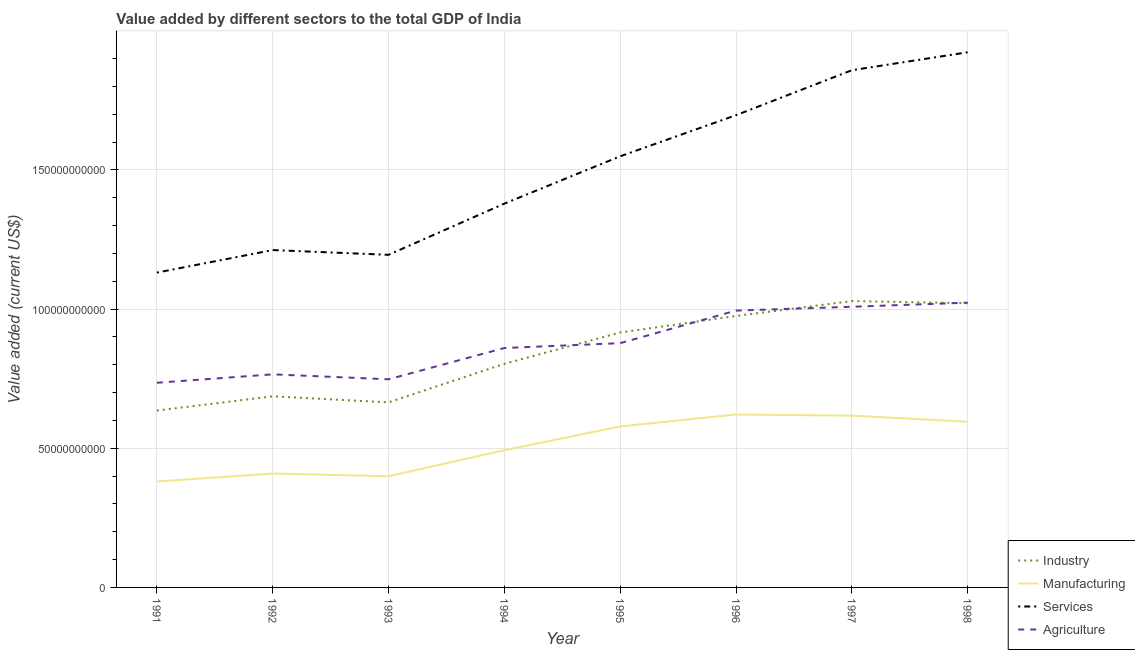Is the number of lines equal to the number of legend labels?
Ensure brevity in your answer.  Yes. What is the value added by industrial sector in 1993?
Keep it short and to the point. 6.65e+1. Across all years, what is the maximum value added by agricultural sector?
Make the answer very short. 1.02e+11. Across all years, what is the minimum value added by services sector?
Your answer should be compact. 1.13e+11. In which year was the value added by services sector maximum?
Your answer should be compact. 1998. In which year was the value added by industrial sector minimum?
Offer a very short reply. 1991. What is the total value added by manufacturing sector in the graph?
Offer a very short reply. 4.09e+11. What is the difference between the value added by services sector in 1992 and that in 1993?
Your answer should be compact. 1.71e+09. What is the difference between the value added by agricultural sector in 1992 and the value added by industrial sector in 1998?
Keep it short and to the point. -2.56e+1. What is the average value added by manufacturing sector per year?
Provide a succinct answer. 5.12e+1. In the year 1997, what is the difference between the value added by agricultural sector and value added by manufacturing sector?
Ensure brevity in your answer.  3.91e+1. In how many years, is the value added by services sector greater than 110000000000 US$?
Provide a succinct answer. 8. What is the ratio of the value added by agricultural sector in 1992 to that in 1998?
Your answer should be compact. 0.75. Is the value added by services sector in 1991 less than that in 1994?
Your response must be concise. Yes. What is the difference between the highest and the second highest value added by services sector?
Make the answer very short. 6.45e+09. What is the difference between the highest and the lowest value added by agricultural sector?
Offer a very short reply. 2.88e+1. Is the sum of the value added by agricultural sector in 1993 and 1995 greater than the maximum value added by industrial sector across all years?
Make the answer very short. Yes. Is the value added by manufacturing sector strictly greater than the value added by agricultural sector over the years?
Give a very brief answer. No. Is the value added by agricultural sector strictly less than the value added by manufacturing sector over the years?
Offer a very short reply. No. What is the difference between two consecutive major ticks on the Y-axis?
Your response must be concise. 5.00e+1. Does the graph contain grids?
Ensure brevity in your answer.  Yes. Where does the legend appear in the graph?
Keep it short and to the point. Bottom right. How many legend labels are there?
Your answer should be very brief. 4. What is the title of the graph?
Offer a terse response. Value added by different sectors to the total GDP of India. Does "Sweden" appear as one of the legend labels in the graph?
Your response must be concise. No. What is the label or title of the Y-axis?
Keep it short and to the point. Value added (current US$). What is the Value added (current US$) in Industry in 1991?
Your answer should be very brief. 6.36e+1. What is the Value added (current US$) of Manufacturing in 1991?
Provide a succinct answer. 3.81e+1. What is the Value added (current US$) in Services in 1991?
Keep it short and to the point. 1.13e+11. What is the Value added (current US$) of Agriculture in 1991?
Ensure brevity in your answer.  7.35e+1. What is the Value added (current US$) of Industry in 1992?
Provide a short and direct response. 6.87e+1. What is the Value added (current US$) in Manufacturing in 1992?
Your answer should be compact. 4.09e+1. What is the Value added (current US$) in Services in 1992?
Offer a very short reply. 1.21e+11. What is the Value added (current US$) of Agriculture in 1992?
Offer a very short reply. 7.66e+1. What is the Value added (current US$) of Industry in 1993?
Give a very brief answer. 6.65e+1. What is the Value added (current US$) in Manufacturing in 1993?
Ensure brevity in your answer.  3.99e+1. What is the Value added (current US$) in Services in 1993?
Offer a terse response. 1.20e+11. What is the Value added (current US$) of Agriculture in 1993?
Keep it short and to the point. 7.48e+1. What is the Value added (current US$) in Industry in 1994?
Give a very brief answer. 8.03e+1. What is the Value added (current US$) of Manufacturing in 1994?
Provide a short and direct response. 4.93e+1. What is the Value added (current US$) of Services in 1994?
Your answer should be compact. 1.38e+11. What is the Value added (current US$) of Agriculture in 1994?
Give a very brief answer. 8.60e+1. What is the Value added (current US$) of Industry in 1995?
Your answer should be compact. 9.16e+1. What is the Value added (current US$) of Manufacturing in 1995?
Offer a very short reply. 5.78e+1. What is the Value added (current US$) in Services in 1995?
Your response must be concise. 1.55e+11. What is the Value added (current US$) of Agriculture in 1995?
Keep it short and to the point. 8.78e+1. What is the Value added (current US$) in Industry in 1996?
Ensure brevity in your answer.  9.75e+1. What is the Value added (current US$) in Manufacturing in 1996?
Offer a terse response. 6.21e+1. What is the Value added (current US$) in Services in 1996?
Offer a very short reply. 1.70e+11. What is the Value added (current US$) of Agriculture in 1996?
Make the answer very short. 9.95e+1. What is the Value added (current US$) in Industry in 1997?
Ensure brevity in your answer.  1.03e+11. What is the Value added (current US$) of Manufacturing in 1997?
Keep it short and to the point. 6.17e+1. What is the Value added (current US$) in Services in 1997?
Offer a very short reply. 1.86e+11. What is the Value added (current US$) of Agriculture in 1997?
Provide a succinct answer. 1.01e+11. What is the Value added (current US$) in Industry in 1998?
Offer a terse response. 1.02e+11. What is the Value added (current US$) in Manufacturing in 1998?
Your response must be concise. 5.95e+1. What is the Value added (current US$) in Services in 1998?
Offer a terse response. 1.92e+11. What is the Value added (current US$) of Agriculture in 1998?
Make the answer very short. 1.02e+11. Across all years, what is the maximum Value added (current US$) in Industry?
Keep it short and to the point. 1.03e+11. Across all years, what is the maximum Value added (current US$) of Manufacturing?
Your answer should be very brief. 6.21e+1. Across all years, what is the maximum Value added (current US$) in Services?
Your answer should be compact. 1.92e+11. Across all years, what is the maximum Value added (current US$) in Agriculture?
Your answer should be compact. 1.02e+11. Across all years, what is the minimum Value added (current US$) of Industry?
Give a very brief answer. 6.36e+1. Across all years, what is the minimum Value added (current US$) in Manufacturing?
Give a very brief answer. 3.81e+1. Across all years, what is the minimum Value added (current US$) in Services?
Offer a terse response. 1.13e+11. Across all years, what is the minimum Value added (current US$) in Agriculture?
Ensure brevity in your answer.  7.35e+1. What is the total Value added (current US$) of Industry in the graph?
Provide a succinct answer. 6.73e+11. What is the total Value added (current US$) in Manufacturing in the graph?
Your response must be concise. 4.09e+11. What is the total Value added (current US$) in Services in the graph?
Your response must be concise. 1.19e+12. What is the total Value added (current US$) of Agriculture in the graph?
Ensure brevity in your answer.  7.01e+11. What is the difference between the Value added (current US$) of Industry in 1991 and that in 1992?
Give a very brief answer. -5.10e+09. What is the difference between the Value added (current US$) of Manufacturing in 1991 and that in 1992?
Your response must be concise. -2.87e+09. What is the difference between the Value added (current US$) of Services in 1991 and that in 1992?
Provide a succinct answer. -8.09e+09. What is the difference between the Value added (current US$) in Agriculture in 1991 and that in 1992?
Provide a short and direct response. -3.02e+09. What is the difference between the Value added (current US$) of Industry in 1991 and that in 1993?
Keep it short and to the point. -2.94e+09. What is the difference between the Value added (current US$) of Manufacturing in 1991 and that in 1993?
Ensure brevity in your answer.  -1.90e+09. What is the difference between the Value added (current US$) of Services in 1991 and that in 1993?
Keep it short and to the point. -6.38e+09. What is the difference between the Value added (current US$) of Agriculture in 1991 and that in 1993?
Keep it short and to the point. -1.25e+09. What is the difference between the Value added (current US$) of Industry in 1991 and that in 1994?
Your response must be concise. -1.68e+1. What is the difference between the Value added (current US$) of Manufacturing in 1991 and that in 1994?
Keep it short and to the point. -1.13e+1. What is the difference between the Value added (current US$) in Services in 1991 and that in 1994?
Your answer should be very brief. -2.48e+1. What is the difference between the Value added (current US$) in Agriculture in 1991 and that in 1994?
Give a very brief answer. -1.25e+1. What is the difference between the Value added (current US$) of Industry in 1991 and that in 1995?
Make the answer very short. -2.80e+1. What is the difference between the Value added (current US$) of Manufacturing in 1991 and that in 1995?
Offer a very short reply. -1.98e+1. What is the difference between the Value added (current US$) in Services in 1991 and that in 1995?
Keep it short and to the point. -4.18e+1. What is the difference between the Value added (current US$) of Agriculture in 1991 and that in 1995?
Offer a terse response. -1.42e+1. What is the difference between the Value added (current US$) of Industry in 1991 and that in 1996?
Your answer should be compact. -3.40e+1. What is the difference between the Value added (current US$) of Manufacturing in 1991 and that in 1996?
Keep it short and to the point. -2.41e+1. What is the difference between the Value added (current US$) in Services in 1991 and that in 1996?
Your answer should be compact. -5.66e+1. What is the difference between the Value added (current US$) in Agriculture in 1991 and that in 1996?
Provide a succinct answer. -2.59e+1. What is the difference between the Value added (current US$) of Industry in 1991 and that in 1997?
Offer a terse response. -3.93e+1. What is the difference between the Value added (current US$) in Manufacturing in 1991 and that in 1997?
Keep it short and to the point. -2.37e+1. What is the difference between the Value added (current US$) of Services in 1991 and that in 1997?
Offer a terse response. -7.27e+1. What is the difference between the Value added (current US$) of Agriculture in 1991 and that in 1997?
Your answer should be very brief. -2.73e+1. What is the difference between the Value added (current US$) of Industry in 1991 and that in 1998?
Your answer should be compact. -3.86e+1. What is the difference between the Value added (current US$) of Manufacturing in 1991 and that in 1998?
Offer a terse response. -2.15e+1. What is the difference between the Value added (current US$) of Services in 1991 and that in 1998?
Provide a succinct answer. -7.92e+1. What is the difference between the Value added (current US$) in Agriculture in 1991 and that in 1998?
Provide a succinct answer. -2.88e+1. What is the difference between the Value added (current US$) in Industry in 1992 and that in 1993?
Provide a succinct answer. 2.17e+09. What is the difference between the Value added (current US$) in Manufacturing in 1992 and that in 1993?
Keep it short and to the point. 9.77e+08. What is the difference between the Value added (current US$) of Services in 1992 and that in 1993?
Offer a very short reply. 1.71e+09. What is the difference between the Value added (current US$) in Agriculture in 1992 and that in 1993?
Give a very brief answer. 1.78e+09. What is the difference between the Value added (current US$) in Industry in 1992 and that in 1994?
Keep it short and to the point. -1.17e+1. What is the difference between the Value added (current US$) in Manufacturing in 1992 and that in 1994?
Provide a short and direct response. -8.38e+09. What is the difference between the Value added (current US$) in Services in 1992 and that in 1994?
Give a very brief answer. -1.67e+1. What is the difference between the Value added (current US$) of Agriculture in 1992 and that in 1994?
Provide a succinct answer. -9.46e+09. What is the difference between the Value added (current US$) of Industry in 1992 and that in 1995?
Your answer should be compact. -2.29e+1. What is the difference between the Value added (current US$) of Manufacturing in 1992 and that in 1995?
Your answer should be very brief. -1.69e+1. What is the difference between the Value added (current US$) of Services in 1992 and that in 1995?
Make the answer very short. -3.37e+1. What is the difference between the Value added (current US$) of Agriculture in 1992 and that in 1995?
Keep it short and to the point. -1.12e+1. What is the difference between the Value added (current US$) in Industry in 1992 and that in 1996?
Ensure brevity in your answer.  -2.89e+1. What is the difference between the Value added (current US$) in Manufacturing in 1992 and that in 1996?
Offer a very short reply. -2.12e+1. What is the difference between the Value added (current US$) of Services in 1992 and that in 1996?
Provide a succinct answer. -4.85e+1. What is the difference between the Value added (current US$) of Agriculture in 1992 and that in 1996?
Provide a short and direct response. -2.29e+1. What is the difference between the Value added (current US$) of Industry in 1992 and that in 1997?
Your response must be concise. -3.42e+1. What is the difference between the Value added (current US$) in Manufacturing in 1992 and that in 1997?
Keep it short and to the point. -2.08e+1. What is the difference between the Value added (current US$) in Services in 1992 and that in 1997?
Offer a terse response. -6.46e+1. What is the difference between the Value added (current US$) in Agriculture in 1992 and that in 1997?
Provide a short and direct response. -2.43e+1. What is the difference between the Value added (current US$) in Industry in 1992 and that in 1998?
Offer a terse response. -3.35e+1. What is the difference between the Value added (current US$) of Manufacturing in 1992 and that in 1998?
Your answer should be compact. -1.86e+1. What is the difference between the Value added (current US$) in Services in 1992 and that in 1998?
Provide a succinct answer. -7.11e+1. What is the difference between the Value added (current US$) in Agriculture in 1992 and that in 1998?
Your response must be concise. -2.58e+1. What is the difference between the Value added (current US$) of Industry in 1993 and that in 1994?
Provide a short and direct response. -1.39e+1. What is the difference between the Value added (current US$) of Manufacturing in 1993 and that in 1994?
Offer a very short reply. -9.36e+09. What is the difference between the Value added (current US$) of Services in 1993 and that in 1994?
Give a very brief answer. -1.84e+1. What is the difference between the Value added (current US$) in Agriculture in 1993 and that in 1994?
Offer a terse response. -1.12e+1. What is the difference between the Value added (current US$) of Industry in 1993 and that in 1995?
Ensure brevity in your answer.  -2.51e+1. What is the difference between the Value added (current US$) of Manufacturing in 1993 and that in 1995?
Offer a terse response. -1.79e+1. What is the difference between the Value added (current US$) in Services in 1993 and that in 1995?
Your answer should be very brief. -3.54e+1. What is the difference between the Value added (current US$) in Agriculture in 1993 and that in 1995?
Give a very brief answer. -1.30e+1. What is the difference between the Value added (current US$) in Industry in 1993 and that in 1996?
Your response must be concise. -3.10e+1. What is the difference between the Value added (current US$) of Manufacturing in 1993 and that in 1996?
Keep it short and to the point. -2.22e+1. What is the difference between the Value added (current US$) in Services in 1993 and that in 1996?
Offer a terse response. -5.02e+1. What is the difference between the Value added (current US$) in Agriculture in 1993 and that in 1996?
Provide a succinct answer. -2.47e+1. What is the difference between the Value added (current US$) in Industry in 1993 and that in 1997?
Your answer should be compact. -3.64e+1. What is the difference between the Value added (current US$) in Manufacturing in 1993 and that in 1997?
Provide a short and direct response. -2.18e+1. What is the difference between the Value added (current US$) in Services in 1993 and that in 1997?
Your answer should be very brief. -6.63e+1. What is the difference between the Value added (current US$) of Agriculture in 1993 and that in 1997?
Your response must be concise. -2.61e+1. What is the difference between the Value added (current US$) of Industry in 1993 and that in 1998?
Keep it short and to the point. -3.56e+1. What is the difference between the Value added (current US$) in Manufacturing in 1993 and that in 1998?
Make the answer very short. -1.96e+1. What is the difference between the Value added (current US$) in Services in 1993 and that in 1998?
Offer a very short reply. -7.28e+1. What is the difference between the Value added (current US$) of Agriculture in 1993 and that in 1998?
Give a very brief answer. -2.75e+1. What is the difference between the Value added (current US$) in Industry in 1994 and that in 1995?
Offer a very short reply. -1.13e+1. What is the difference between the Value added (current US$) in Manufacturing in 1994 and that in 1995?
Provide a short and direct response. -8.54e+09. What is the difference between the Value added (current US$) in Services in 1994 and that in 1995?
Provide a succinct answer. -1.70e+1. What is the difference between the Value added (current US$) of Agriculture in 1994 and that in 1995?
Make the answer very short. -1.74e+09. What is the difference between the Value added (current US$) of Industry in 1994 and that in 1996?
Your response must be concise. -1.72e+1. What is the difference between the Value added (current US$) of Manufacturing in 1994 and that in 1996?
Provide a short and direct response. -1.28e+1. What is the difference between the Value added (current US$) of Services in 1994 and that in 1996?
Your response must be concise. -3.18e+1. What is the difference between the Value added (current US$) of Agriculture in 1994 and that in 1996?
Offer a very short reply. -1.34e+1. What is the difference between the Value added (current US$) in Industry in 1994 and that in 1997?
Ensure brevity in your answer.  -2.25e+1. What is the difference between the Value added (current US$) of Manufacturing in 1994 and that in 1997?
Keep it short and to the point. -1.24e+1. What is the difference between the Value added (current US$) in Services in 1994 and that in 1997?
Provide a succinct answer. -4.79e+1. What is the difference between the Value added (current US$) in Agriculture in 1994 and that in 1997?
Provide a succinct answer. -1.48e+1. What is the difference between the Value added (current US$) in Industry in 1994 and that in 1998?
Keep it short and to the point. -2.18e+1. What is the difference between the Value added (current US$) in Manufacturing in 1994 and that in 1998?
Provide a succinct answer. -1.02e+1. What is the difference between the Value added (current US$) of Services in 1994 and that in 1998?
Provide a succinct answer. -5.44e+1. What is the difference between the Value added (current US$) of Agriculture in 1994 and that in 1998?
Offer a very short reply. -1.63e+1. What is the difference between the Value added (current US$) in Industry in 1995 and that in 1996?
Make the answer very short. -5.94e+09. What is the difference between the Value added (current US$) in Manufacturing in 1995 and that in 1996?
Your answer should be compact. -4.29e+09. What is the difference between the Value added (current US$) in Services in 1995 and that in 1996?
Provide a succinct answer. -1.48e+1. What is the difference between the Value added (current US$) of Agriculture in 1995 and that in 1996?
Provide a short and direct response. -1.17e+1. What is the difference between the Value added (current US$) of Industry in 1995 and that in 1997?
Keep it short and to the point. -1.13e+1. What is the difference between the Value added (current US$) of Manufacturing in 1995 and that in 1997?
Provide a short and direct response. -3.89e+09. What is the difference between the Value added (current US$) of Services in 1995 and that in 1997?
Keep it short and to the point. -3.09e+1. What is the difference between the Value added (current US$) in Agriculture in 1995 and that in 1997?
Offer a very short reply. -1.31e+1. What is the difference between the Value added (current US$) of Industry in 1995 and that in 1998?
Offer a very short reply. -1.05e+1. What is the difference between the Value added (current US$) of Manufacturing in 1995 and that in 1998?
Give a very brief answer. -1.68e+09. What is the difference between the Value added (current US$) in Services in 1995 and that in 1998?
Provide a succinct answer. -3.74e+1. What is the difference between the Value added (current US$) of Agriculture in 1995 and that in 1998?
Your answer should be compact. -1.46e+1. What is the difference between the Value added (current US$) in Industry in 1996 and that in 1997?
Your answer should be compact. -5.35e+09. What is the difference between the Value added (current US$) of Manufacturing in 1996 and that in 1997?
Keep it short and to the point. 3.95e+08. What is the difference between the Value added (current US$) in Services in 1996 and that in 1997?
Your answer should be very brief. -1.62e+1. What is the difference between the Value added (current US$) in Agriculture in 1996 and that in 1997?
Offer a terse response. -1.38e+09. What is the difference between the Value added (current US$) in Industry in 1996 and that in 1998?
Make the answer very short. -4.59e+09. What is the difference between the Value added (current US$) in Manufacturing in 1996 and that in 1998?
Your answer should be very brief. 2.61e+09. What is the difference between the Value added (current US$) of Services in 1996 and that in 1998?
Ensure brevity in your answer.  -2.26e+1. What is the difference between the Value added (current US$) in Agriculture in 1996 and that in 1998?
Provide a succinct answer. -2.85e+09. What is the difference between the Value added (current US$) in Industry in 1997 and that in 1998?
Ensure brevity in your answer.  7.66e+08. What is the difference between the Value added (current US$) of Manufacturing in 1997 and that in 1998?
Give a very brief answer. 2.21e+09. What is the difference between the Value added (current US$) in Services in 1997 and that in 1998?
Your response must be concise. -6.45e+09. What is the difference between the Value added (current US$) of Agriculture in 1997 and that in 1998?
Ensure brevity in your answer.  -1.47e+09. What is the difference between the Value added (current US$) in Industry in 1991 and the Value added (current US$) in Manufacturing in 1992?
Make the answer very short. 2.26e+1. What is the difference between the Value added (current US$) in Industry in 1991 and the Value added (current US$) in Services in 1992?
Your answer should be very brief. -5.77e+1. What is the difference between the Value added (current US$) of Industry in 1991 and the Value added (current US$) of Agriculture in 1992?
Make the answer very short. -1.30e+1. What is the difference between the Value added (current US$) of Manufacturing in 1991 and the Value added (current US$) of Services in 1992?
Provide a succinct answer. -8.32e+1. What is the difference between the Value added (current US$) of Manufacturing in 1991 and the Value added (current US$) of Agriculture in 1992?
Keep it short and to the point. -3.85e+1. What is the difference between the Value added (current US$) of Services in 1991 and the Value added (current US$) of Agriculture in 1992?
Provide a succinct answer. 3.66e+1. What is the difference between the Value added (current US$) in Industry in 1991 and the Value added (current US$) in Manufacturing in 1993?
Your answer should be compact. 2.36e+1. What is the difference between the Value added (current US$) of Industry in 1991 and the Value added (current US$) of Services in 1993?
Ensure brevity in your answer.  -5.59e+1. What is the difference between the Value added (current US$) of Industry in 1991 and the Value added (current US$) of Agriculture in 1993?
Your response must be concise. -1.12e+1. What is the difference between the Value added (current US$) in Manufacturing in 1991 and the Value added (current US$) in Services in 1993?
Your response must be concise. -8.15e+1. What is the difference between the Value added (current US$) in Manufacturing in 1991 and the Value added (current US$) in Agriculture in 1993?
Keep it short and to the point. -3.67e+1. What is the difference between the Value added (current US$) of Services in 1991 and the Value added (current US$) of Agriculture in 1993?
Your answer should be compact. 3.83e+1. What is the difference between the Value added (current US$) of Industry in 1991 and the Value added (current US$) of Manufacturing in 1994?
Make the answer very short. 1.43e+1. What is the difference between the Value added (current US$) of Industry in 1991 and the Value added (current US$) of Services in 1994?
Provide a short and direct response. -7.44e+1. What is the difference between the Value added (current US$) of Industry in 1991 and the Value added (current US$) of Agriculture in 1994?
Offer a terse response. -2.25e+1. What is the difference between the Value added (current US$) in Manufacturing in 1991 and the Value added (current US$) in Services in 1994?
Provide a succinct answer. -9.99e+1. What is the difference between the Value added (current US$) in Manufacturing in 1991 and the Value added (current US$) in Agriculture in 1994?
Offer a terse response. -4.80e+1. What is the difference between the Value added (current US$) in Services in 1991 and the Value added (current US$) in Agriculture in 1994?
Offer a very short reply. 2.71e+1. What is the difference between the Value added (current US$) in Industry in 1991 and the Value added (current US$) in Manufacturing in 1995?
Make the answer very short. 5.71e+09. What is the difference between the Value added (current US$) of Industry in 1991 and the Value added (current US$) of Services in 1995?
Provide a short and direct response. -9.14e+1. What is the difference between the Value added (current US$) of Industry in 1991 and the Value added (current US$) of Agriculture in 1995?
Offer a very short reply. -2.42e+1. What is the difference between the Value added (current US$) in Manufacturing in 1991 and the Value added (current US$) in Services in 1995?
Offer a terse response. -1.17e+11. What is the difference between the Value added (current US$) of Manufacturing in 1991 and the Value added (current US$) of Agriculture in 1995?
Your answer should be very brief. -4.97e+1. What is the difference between the Value added (current US$) in Services in 1991 and the Value added (current US$) in Agriculture in 1995?
Keep it short and to the point. 2.54e+1. What is the difference between the Value added (current US$) of Industry in 1991 and the Value added (current US$) of Manufacturing in 1996?
Give a very brief answer. 1.43e+09. What is the difference between the Value added (current US$) of Industry in 1991 and the Value added (current US$) of Services in 1996?
Make the answer very short. -1.06e+11. What is the difference between the Value added (current US$) in Industry in 1991 and the Value added (current US$) in Agriculture in 1996?
Your response must be concise. -3.59e+1. What is the difference between the Value added (current US$) of Manufacturing in 1991 and the Value added (current US$) of Services in 1996?
Give a very brief answer. -1.32e+11. What is the difference between the Value added (current US$) of Manufacturing in 1991 and the Value added (current US$) of Agriculture in 1996?
Ensure brevity in your answer.  -6.14e+1. What is the difference between the Value added (current US$) of Services in 1991 and the Value added (current US$) of Agriculture in 1996?
Provide a succinct answer. 1.37e+1. What is the difference between the Value added (current US$) in Industry in 1991 and the Value added (current US$) in Manufacturing in 1997?
Give a very brief answer. 1.82e+09. What is the difference between the Value added (current US$) of Industry in 1991 and the Value added (current US$) of Services in 1997?
Make the answer very short. -1.22e+11. What is the difference between the Value added (current US$) in Industry in 1991 and the Value added (current US$) in Agriculture in 1997?
Your response must be concise. -3.73e+1. What is the difference between the Value added (current US$) of Manufacturing in 1991 and the Value added (current US$) of Services in 1997?
Your response must be concise. -1.48e+11. What is the difference between the Value added (current US$) in Manufacturing in 1991 and the Value added (current US$) in Agriculture in 1997?
Provide a short and direct response. -6.28e+1. What is the difference between the Value added (current US$) of Services in 1991 and the Value added (current US$) of Agriculture in 1997?
Offer a terse response. 1.23e+1. What is the difference between the Value added (current US$) of Industry in 1991 and the Value added (current US$) of Manufacturing in 1998?
Your answer should be very brief. 4.04e+09. What is the difference between the Value added (current US$) of Industry in 1991 and the Value added (current US$) of Services in 1998?
Give a very brief answer. -1.29e+11. What is the difference between the Value added (current US$) of Industry in 1991 and the Value added (current US$) of Agriculture in 1998?
Offer a very short reply. -3.88e+1. What is the difference between the Value added (current US$) of Manufacturing in 1991 and the Value added (current US$) of Services in 1998?
Your response must be concise. -1.54e+11. What is the difference between the Value added (current US$) of Manufacturing in 1991 and the Value added (current US$) of Agriculture in 1998?
Provide a short and direct response. -6.43e+1. What is the difference between the Value added (current US$) of Services in 1991 and the Value added (current US$) of Agriculture in 1998?
Keep it short and to the point. 1.08e+1. What is the difference between the Value added (current US$) of Industry in 1992 and the Value added (current US$) of Manufacturing in 1993?
Your answer should be compact. 2.87e+1. What is the difference between the Value added (current US$) in Industry in 1992 and the Value added (current US$) in Services in 1993?
Make the answer very short. -5.08e+1. What is the difference between the Value added (current US$) in Industry in 1992 and the Value added (current US$) in Agriculture in 1993?
Your response must be concise. -6.12e+09. What is the difference between the Value added (current US$) of Manufacturing in 1992 and the Value added (current US$) of Services in 1993?
Offer a very short reply. -7.86e+1. What is the difference between the Value added (current US$) of Manufacturing in 1992 and the Value added (current US$) of Agriculture in 1993?
Keep it short and to the point. -3.39e+1. What is the difference between the Value added (current US$) of Services in 1992 and the Value added (current US$) of Agriculture in 1993?
Ensure brevity in your answer.  4.64e+1. What is the difference between the Value added (current US$) in Industry in 1992 and the Value added (current US$) in Manufacturing in 1994?
Make the answer very short. 1.94e+1. What is the difference between the Value added (current US$) in Industry in 1992 and the Value added (current US$) in Services in 1994?
Offer a terse response. -6.92e+1. What is the difference between the Value added (current US$) in Industry in 1992 and the Value added (current US$) in Agriculture in 1994?
Your response must be concise. -1.74e+1. What is the difference between the Value added (current US$) of Manufacturing in 1992 and the Value added (current US$) of Services in 1994?
Your answer should be very brief. -9.70e+1. What is the difference between the Value added (current US$) of Manufacturing in 1992 and the Value added (current US$) of Agriculture in 1994?
Your answer should be very brief. -4.51e+1. What is the difference between the Value added (current US$) of Services in 1992 and the Value added (current US$) of Agriculture in 1994?
Make the answer very short. 3.52e+1. What is the difference between the Value added (current US$) of Industry in 1992 and the Value added (current US$) of Manufacturing in 1995?
Your answer should be very brief. 1.08e+1. What is the difference between the Value added (current US$) of Industry in 1992 and the Value added (current US$) of Services in 1995?
Your response must be concise. -8.63e+1. What is the difference between the Value added (current US$) of Industry in 1992 and the Value added (current US$) of Agriculture in 1995?
Give a very brief answer. -1.91e+1. What is the difference between the Value added (current US$) in Manufacturing in 1992 and the Value added (current US$) in Services in 1995?
Keep it short and to the point. -1.14e+11. What is the difference between the Value added (current US$) in Manufacturing in 1992 and the Value added (current US$) in Agriculture in 1995?
Your response must be concise. -4.68e+1. What is the difference between the Value added (current US$) of Services in 1992 and the Value added (current US$) of Agriculture in 1995?
Your response must be concise. 3.34e+1. What is the difference between the Value added (current US$) in Industry in 1992 and the Value added (current US$) in Manufacturing in 1996?
Offer a terse response. 6.53e+09. What is the difference between the Value added (current US$) in Industry in 1992 and the Value added (current US$) in Services in 1996?
Ensure brevity in your answer.  -1.01e+11. What is the difference between the Value added (current US$) of Industry in 1992 and the Value added (current US$) of Agriculture in 1996?
Ensure brevity in your answer.  -3.08e+1. What is the difference between the Value added (current US$) in Manufacturing in 1992 and the Value added (current US$) in Services in 1996?
Offer a terse response. -1.29e+11. What is the difference between the Value added (current US$) in Manufacturing in 1992 and the Value added (current US$) in Agriculture in 1996?
Provide a succinct answer. -5.85e+1. What is the difference between the Value added (current US$) in Services in 1992 and the Value added (current US$) in Agriculture in 1996?
Your response must be concise. 2.17e+1. What is the difference between the Value added (current US$) in Industry in 1992 and the Value added (current US$) in Manufacturing in 1997?
Give a very brief answer. 6.93e+09. What is the difference between the Value added (current US$) of Industry in 1992 and the Value added (current US$) of Services in 1997?
Offer a terse response. -1.17e+11. What is the difference between the Value added (current US$) of Industry in 1992 and the Value added (current US$) of Agriculture in 1997?
Provide a short and direct response. -3.22e+1. What is the difference between the Value added (current US$) of Manufacturing in 1992 and the Value added (current US$) of Services in 1997?
Provide a succinct answer. -1.45e+11. What is the difference between the Value added (current US$) in Manufacturing in 1992 and the Value added (current US$) in Agriculture in 1997?
Make the answer very short. -5.99e+1. What is the difference between the Value added (current US$) in Services in 1992 and the Value added (current US$) in Agriculture in 1997?
Make the answer very short. 2.04e+1. What is the difference between the Value added (current US$) of Industry in 1992 and the Value added (current US$) of Manufacturing in 1998?
Offer a very short reply. 9.14e+09. What is the difference between the Value added (current US$) of Industry in 1992 and the Value added (current US$) of Services in 1998?
Provide a short and direct response. -1.24e+11. What is the difference between the Value added (current US$) in Industry in 1992 and the Value added (current US$) in Agriculture in 1998?
Provide a short and direct response. -3.37e+1. What is the difference between the Value added (current US$) of Manufacturing in 1992 and the Value added (current US$) of Services in 1998?
Ensure brevity in your answer.  -1.51e+11. What is the difference between the Value added (current US$) in Manufacturing in 1992 and the Value added (current US$) in Agriculture in 1998?
Your answer should be very brief. -6.14e+1. What is the difference between the Value added (current US$) in Services in 1992 and the Value added (current US$) in Agriculture in 1998?
Offer a terse response. 1.89e+1. What is the difference between the Value added (current US$) in Industry in 1993 and the Value added (current US$) in Manufacturing in 1994?
Provide a succinct answer. 1.72e+1. What is the difference between the Value added (current US$) of Industry in 1993 and the Value added (current US$) of Services in 1994?
Provide a succinct answer. -7.14e+1. What is the difference between the Value added (current US$) of Industry in 1993 and the Value added (current US$) of Agriculture in 1994?
Offer a very short reply. -1.95e+1. What is the difference between the Value added (current US$) of Manufacturing in 1993 and the Value added (current US$) of Services in 1994?
Keep it short and to the point. -9.80e+1. What is the difference between the Value added (current US$) in Manufacturing in 1993 and the Value added (current US$) in Agriculture in 1994?
Give a very brief answer. -4.61e+1. What is the difference between the Value added (current US$) in Services in 1993 and the Value added (current US$) in Agriculture in 1994?
Provide a succinct answer. 3.35e+1. What is the difference between the Value added (current US$) of Industry in 1993 and the Value added (current US$) of Manufacturing in 1995?
Provide a succinct answer. 8.65e+09. What is the difference between the Value added (current US$) in Industry in 1993 and the Value added (current US$) in Services in 1995?
Offer a terse response. -8.84e+1. What is the difference between the Value added (current US$) of Industry in 1993 and the Value added (current US$) of Agriculture in 1995?
Give a very brief answer. -2.13e+1. What is the difference between the Value added (current US$) of Manufacturing in 1993 and the Value added (current US$) of Services in 1995?
Offer a very short reply. -1.15e+11. What is the difference between the Value added (current US$) in Manufacturing in 1993 and the Value added (current US$) in Agriculture in 1995?
Offer a terse response. -4.78e+1. What is the difference between the Value added (current US$) in Services in 1993 and the Value added (current US$) in Agriculture in 1995?
Your answer should be compact. 3.17e+1. What is the difference between the Value added (current US$) of Industry in 1993 and the Value added (current US$) of Manufacturing in 1996?
Offer a very short reply. 4.36e+09. What is the difference between the Value added (current US$) in Industry in 1993 and the Value added (current US$) in Services in 1996?
Keep it short and to the point. -1.03e+11. What is the difference between the Value added (current US$) in Industry in 1993 and the Value added (current US$) in Agriculture in 1996?
Make the answer very short. -3.30e+1. What is the difference between the Value added (current US$) of Manufacturing in 1993 and the Value added (current US$) of Services in 1996?
Provide a short and direct response. -1.30e+11. What is the difference between the Value added (current US$) of Manufacturing in 1993 and the Value added (current US$) of Agriculture in 1996?
Keep it short and to the point. -5.95e+1. What is the difference between the Value added (current US$) in Services in 1993 and the Value added (current US$) in Agriculture in 1996?
Offer a very short reply. 2.00e+1. What is the difference between the Value added (current US$) in Industry in 1993 and the Value added (current US$) in Manufacturing in 1997?
Provide a short and direct response. 4.76e+09. What is the difference between the Value added (current US$) of Industry in 1993 and the Value added (current US$) of Services in 1997?
Your answer should be very brief. -1.19e+11. What is the difference between the Value added (current US$) of Industry in 1993 and the Value added (current US$) of Agriculture in 1997?
Your answer should be very brief. -3.44e+1. What is the difference between the Value added (current US$) of Manufacturing in 1993 and the Value added (current US$) of Services in 1997?
Offer a very short reply. -1.46e+11. What is the difference between the Value added (current US$) in Manufacturing in 1993 and the Value added (current US$) in Agriculture in 1997?
Make the answer very short. -6.09e+1. What is the difference between the Value added (current US$) in Services in 1993 and the Value added (current US$) in Agriculture in 1997?
Provide a short and direct response. 1.87e+1. What is the difference between the Value added (current US$) in Industry in 1993 and the Value added (current US$) in Manufacturing in 1998?
Ensure brevity in your answer.  6.97e+09. What is the difference between the Value added (current US$) of Industry in 1993 and the Value added (current US$) of Services in 1998?
Ensure brevity in your answer.  -1.26e+11. What is the difference between the Value added (current US$) in Industry in 1993 and the Value added (current US$) in Agriculture in 1998?
Provide a succinct answer. -3.58e+1. What is the difference between the Value added (current US$) in Manufacturing in 1993 and the Value added (current US$) in Services in 1998?
Offer a terse response. -1.52e+11. What is the difference between the Value added (current US$) of Manufacturing in 1993 and the Value added (current US$) of Agriculture in 1998?
Your response must be concise. -6.24e+1. What is the difference between the Value added (current US$) of Services in 1993 and the Value added (current US$) of Agriculture in 1998?
Offer a very short reply. 1.72e+1. What is the difference between the Value added (current US$) of Industry in 1994 and the Value added (current US$) of Manufacturing in 1995?
Your answer should be very brief. 2.25e+1. What is the difference between the Value added (current US$) of Industry in 1994 and the Value added (current US$) of Services in 1995?
Provide a short and direct response. -7.46e+1. What is the difference between the Value added (current US$) in Industry in 1994 and the Value added (current US$) in Agriculture in 1995?
Your answer should be compact. -7.42e+09. What is the difference between the Value added (current US$) in Manufacturing in 1994 and the Value added (current US$) in Services in 1995?
Keep it short and to the point. -1.06e+11. What is the difference between the Value added (current US$) of Manufacturing in 1994 and the Value added (current US$) of Agriculture in 1995?
Keep it short and to the point. -3.85e+1. What is the difference between the Value added (current US$) of Services in 1994 and the Value added (current US$) of Agriculture in 1995?
Offer a terse response. 5.01e+1. What is the difference between the Value added (current US$) in Industry in 1994 and the Value added (current US$) in Manufacturing in 1996?
Give a very brief answer. 1.82e+1. What is the difference between the Value added (current US$) in Industry in 1994 and the Value added (current US$) in Services in 1996?
Provide a succinct answer. -8.93e+1. What is the difference between the Value added (current US$) in Industry in 1994 and the Value added (current US$) in Agriculture in 1996?
Provide a succinct answer. -1.91e+1. What is the difference between the Value added (current US$) in Manufacturing in 1994 and the Value added (current US$) in Services in 1996?
Offer a very short reply. -1.20e+11. What is the difference between the Value added (current US$) in Manufacturing in 1994 and the Value added (current US$) in Agriculture in 1996?
Give a very brief answer. -5.02e+1. What is the difference between the Value added (current US$) of Services in 1994 and the Value added (current US$) of Agriculture in 1996?
Offer a very short reply. 3.84e+1. What is the difference between the Value added (current US$) of Industry in 1994 and the Value added (current US$) of Manufacturing in 1997?
Make the answer very short. 1.86e+1. What is the difference between the Value added (current US$) in Industry in 1994 and the Value added (current US$) in Services in 1997?
Provide a succinct answer. -1.05e+11. What is the difference between the Value added (current US$) of Industry in 1994 and the Value added (current US$) of Agriculture in 1997?
Your answer should be compact. -2.05e+1. What is the difference between the Value added (current US$) of Manufacturing in 1994 and the Value added (current US$) of Services in 1997?
Offer a very short reply. -1.37e+11. What is the difference between the Value added (current US$) in Manufacturing in 1994 and the Value added (current US$) in Agriculture in 1997?
Give a very brief answer. -5.15e+1. What is the difference between the Value added (current US$) in Services in 1994 and the Value added (current US$) in Agriculture in 1997?
Your answer should be very brief. 3.71e+1. What is the difference between the Value added (current US$) of Industry in 1994 and the Value added (current US$) of Manufacturing in 1998?
Give a very brief answer. 2.08e+1. What is the difference between the Value added (current US$) of Industry in 1994 and the Value added (current US$) of Services in 1998?
Your answer should be very brief. -1.12e+11. What is the difference between the Value added (current US$) of Industry in 1994 and the Value added (current US$) of Agriculture in 1998?
Give a very brief answer. -2.20e+1. What is the difference between the Value added (current US$) in Manufacturing in 1994 and the Value added (current US$) in Services in 1998?
Give a very brief answer. -1.43e+11. What is the difference between the Value added (current US$) of Manufacturing in 1994 and the Value added (current US$) of Agriculture in 1998?
Offer a very short reply. -5.30e+1. What is the difference between the Value added (current US$) of Services in 1994 and the Value added (current US$) of Agriculture in 1998?
Ensure brevity in your answer.  3.56e+1. What is the difference between the Value added (current US$) in Industry in 1995 and the Value added (current US$) in Manufacturing in 1996?
Provide a succinct answer. 2.95e+1. What is the difference between the Value added (current US$) of Industry in 1995 and the Value added (current US$) of Services in 1996?
Your answer should be very brief. -7.81e+1. What is the difference between the Value added (current US$) in Industry in 1995 and the Value added (current US$) in Agriculture in 1996?
Your response must be concise. -7.87e+09. What is the difference between the Value added (current US$) of Manufacturing in 1995 and the Value added (current US$) of Services in 1996?
Your response must be concise. -1.12e+11. What is the difference between the Value added (current US$) of Manufacturing in 1995 and the Value added (current US$) of Agriculture in 1996?
Give a very brief answer. -4.16e+1. What is the difference between the Value added (current US$) in Services in 1995 and the Value added (current US$) in Agriculture in 1996?
Your answer should be compact. 5.54e+1. What is the difference between the Value added (current US$) in Industry in 1995 and the Value added (current US$) in Manufacturing in 1997?
Make the answer very short. 2.99e+1. What is the difference between the Value added (current US$) of Industry in 1995 and the Value added (current US$) of Services in 1997?
Provide a short and direct response. -9.42e+1. What is the difference between the Value added (current US$) of Industry in 1995 and the Value added (current US$) of Agriculture in 1997?
Your response must be concise. -9.25e+09. What is the difference between the Value added (current US$) in Manufacturing in 1995 and the Value added (current US$) in Services in 1997?
Offer a very short reply. -1.28e+11. What is the difference between the Value added (current US$) in Manufacturing in 1995 and the Value added (current US$) in Agriculture in 1997?
Provide a short and direct response. -4.30e+1. What is the difference between the Value added (current US$) in Services in 1995 and the Value added (current US$) in Agriculture in 1997?
Give a very brief answer. 5.41e+1. What is the difference between the Value added (current US$) in Industry in 1995 and the Value added (current US$) in Manufacturing in 1998?
Make the answer very short. 3.21e+1. What is the difference between the Value added (current US$) of Industry in 1995 and the Value added (current US$) of Services in 1998?
Your answer should be very brief. -1.01e+11. What is the difference between the Value added (current US$) in Industry in 1995 and the Value added (current US$) in Agriculture in 1998?
Your answer should be compact. -1.07e+1. What is the difference between the Value added (current US$) of Manufacturing in 1995 and the Value added (current US$) of Services in 1998?
Give a very brief answer. -1.34e+11. What is the difference between the Value added (current US$) in Manufacturing in 1995 and the Value added (current US$) in Agriculture in 1998?
Provide a succinct answer. -4.45e+1. What is the difference between the Value added (current US$) of Services in 1995 and the Value added (current US$) of Agriculture in 1998?
Make the answer very short. 5.26e+1. What is the difference between the Value added (current US$) in Industry in 1996 and the Value added (current US$) in Manufacturing in 1997?
Offer a very short reply. 3.58e+1. What is the difference between the Value added (current US$) of Industry in 1996 and the Value added (current US$) of Services in 1997?
Keep it short and to the point. -8.83e+1. What is the difference between the Value added (current US$) in Industry in 1996 and the Value added (current US$) in Agriculture in 1997?
Your answer should be compact. -3.31e+09. What is the difference between the Value added (current US$) in Manufacturing in 1996 and the Value added (current US$) in Services in 1997?
Give a very brief answer. -1.24e+11. What is the difference between the Value added (current US$) in Manufacturing in 1996 and the Value added (current US$) in Agriculture in 1997?
Keep it short and to the point. -3.87e+1. What is the difference between the Value added (current US$) of Services in 1996 and the Value added (current US$) of Agriculture in 1997?
Your response must be concise. 6.88e+1. What is the difference between the Value added (current US$) of Industry in 1996 and the Value added (current US$) of Manufacturing in 1998?
Offer a very short reply. 3.80e+1. What is the difference between the Value added (current US$) of Industry in 1996 and the Value added (current US$) of Services in 1998?
Provide a succinct answer. -9.48e+1. What is the difference between the Value added (current US$) in Industry in 1996 and the Value added (current US$) in Agriculture in 1998?
Make the answer very short. -4.78e+09. What is the difference between the Value added (current US$) of Manufacturing in 1996 and the Value added (current US$) of Services in 1998?
Offer a terse response. -1.30e+11. What is the difference between the Value added (current US$) of Manufacturing in 1996 and the Value added (current US$) of Agriculture in 1998?
Provide a short and direct response. -4.02e+1. What is the difference between the Value added (current US$) in Services in 1996 and the Value added (current US$) in Agriculture in 1998?
Keep it short and to the point. 6.74e+1. What is the difference between the Value added (current US$) in Industry in 1997 and the Value added (current US$) in Manufacturing in 1998?
Keep it short and to the point. 4.34e+1. What is the difference between the Value added (current US$) in Industry in 1997 and the Value added (current US$) in Services in 1998?
Offer a very short reply. -8.94e+1. What is the difference between the Value added (current US$) in Industry in 1997 and the Value added (current US$) in Agriculture in 1998?
Your response must be concise. 5.68e+08. What is the difference between the Value added (current US$) in Manufacturing in 1997 and the Value added (current US$) in Services in 1998?
Your answer should be very brief. -1.31e+11. What is the difference between the Value added (current US$) of Manufacturing in 1997 and the Value added (current US$) of Agriculture in 1998?
Offer a terse response. -4.06e+1. What is the difference between the Value added (current US$) of Services in 1997 and the Value added (current US$) of Agriculture in 1998?
Offer a very short reply. 8.35e+1. What is the average Value added (current US$) of Industry per year?
Provide a succinct answer. 8.42e+1. What is the average Value added (current US$) in Manufacturing per year?
Provide a succinct answer. 5.12e+1. What is the average Value added (current US$) of Services per year?
Keep it short and to the point. 1.49e+11. What is the average Value added (current US$) in Agriculture per year?
Give a very brief answer. 8.77e+1. In the year 1991, what is the difference between the Value added (current US$) in Industry and Value added (current US$) in Manufacturing?
Offer a terse response. 2.55e+1. In the year 1991, what is the difference between the Value added (current US$) in Industry and Value added (current US$) in Services?
Ensure brevity in your answer.  -4.96e+1. In the year 1991, what is the difference between the Value added (current US$) of Industry and Value added (current US$) of Agriculture?
Ensure brevity in your answer.  -9.98e+09. In the year 1991, what is the difference between the Value added (current US$) of Manufacturing and Value added (current US$) of Services?
Ensure brevity in your answer.  -7.51e+1. In the year 1991, what is the difference between the Value added (current US$) in Manufacturing and Value added (current US$) in Agriculture?
Your response must be concise. -3.55e+1. In the year 1991, what is the difference between the Value added (current US$) of Services and Value added (current US$) of Agriculture?
Make the answer very short. 3.96e+1. In the year 1992, what is the difference between the Value added (current US$) of Industry and Value added (current US$) of Manufacturing?
Ensure brevity in your answer.  2.77e+1. In the year 1992, what is the difference between the Value added (current US$) in Industry and Value added (current US$) in Services?
Your answer should be compact. -5.26e+1. In the year 1992, what is the difference between the Value added (current US$) in Industry and Value added (current US$) in Agriculture?
Offer a terse response. -7.90e+09. In the year 1992, what is the difference between the Value added (current US$) in Manufacturing and Value added (current US$) in Services?
Offer a terse response. -8.03e+1. In the year 1992, what is the difference between the Value added (current US$) of Manufacturing and Value added (current US$) of Agriculture?
Ensure brevity in your answer.  -3.56e+1. In the year 1992, what is the difference between the Value added (current US$) of Services and Value added (current US$) of Agriculture?
Make the answer very short. 4.47e+1. In the year 1993, what is the difference between the Value added (current US$) in Industry and Value added (current US$) in Manufacturing?
Your answer should be compact. 2.65e+1. In the year 1993, what is the difference between the Value added (current US$) in Industry and Value added (current US$) in Services?
Offer a very short reply. -5.30e+1. In the year 1993, what is the difference between the Value added (current US$) in Industry and Value added (current US$) in Agriculture?
Your answer should be very brief. -8.29e+09. In the year 1993, what is the difference between the Value added (current US$) in Manufacturing and Value added (current US$) in Services?
Provide a short and direct response. -7.96e+1. In the year 1993, what is the difference between the Value added (current US$) in Manufacturing and Value added (current US$) in Agriculture?
Keep it short and to the point. -3.48e+1. In the year 1993, what is the difference between the Value added (current US$) of Services and Value added (current US$) of Agriculture?
Provide a short and direct response. 4.47e+1. In the year 1994, what is the difference between the Value added (current US$) of Industry and Value added (current US$) of Manufacturing?
Make the answer very short. 3.10e+1. In the year 1994, what is the difference between the Value added (current US$) of Industry and Value added (current US$) of Services?
Provide a short and direct response. -5.76e+1. In the year 1994, what is the difference between the Value added (current US$) of Industry and Value added (current US$) of Agriculture?
Ensure brevity in your answer.  -5.68e+09. In the year 1994, what is the difference between the Value added (current US$) in Manufacturing and Value added (current US$) in Services?
Your response must be concise. -8.86e+1. In the year 1994, what is the difference between the Value added (current US$) in Manufacturing and Value added (current US$) in Agriculture?
Ensure brevity in your answer.  -3.67e+1. In the year 1994, what is the difference between the Value added (current US$) in Services and Value added (current US$) in Agriculture?
Provide a succinct answer. 5.19e+1. In the year 1995, what is the difference between the Value added (current US$) of Industry and Value added (current US$) of Manufacturing?
Provide a short and direct response. 3.38e+1. In the year 1995, what is the difference between the Value added (current US$) in Industry and Value added (current US$) in Services?
Offer a terse response. -6.33e+1. In the year 1995, what is the difference between the Value added (current US$) in Industry and Value added (current US$) in Agriculture?
Keep it short and to the point. 3.83e+09. In the year 1995, what is the difference between the Value added (current US$) of Manufacturing and Value added (current US$) of Services?
Keep it short and to the point. -9.71e+1. In the year 1995, what is the difference between the Value added (current US$) in Manufacturing and Value added (current US$) in Agriculture?
Offer a terse response. -2.99e+1. In the year 1995, what is the difference between the Value added (current US$) of Services and Value added (current US$) of Agriculture?
Provide a short and direct response. 6.71e+1. In the year 1996, what is the difference between the Value added (current US$) in Industry and Value added (current US$) in Manufacturing?
Your answer should be compact. 3.54e+1. In the year 1996, what is the difference between the Value added (current US$) in Industry and Value added (current US$) in Services?
Offer a terse response. -7.21e+1. In the year 1996, what is the difference between the Value added (current US$) of Industry and Value added (current US$) of Agriculture?
Your response must be concise. -1.94e+09. In the year 1996, what is the difference between the Value added (current US$) in Manufacturing and Value added (current US$) in Services?
Provide a short and direct response. -1.08e+11. In the year 1996, what is the difference between the Value added (current US$) in Manufacturing and Value added (current US$) in Agriculture?
Ensure brevity in your answer.  -3.73e+1. In the year 1996, what is the difference between the Value added (current US$) of Services and Value added (current US$) of Agriculture?
Give a very brief answer. 7.02e+1. In the year 1997, what is the difference between the Value added (current US$) of Industry and Value added (current US$) of Manufacturing?
Your response must be concise. 4.12e+1. In the year 1997, what is the difference between the Value added (current US$) of Industry and Value added (current US$) of Services?
Offer a very short reply. -8.30e+1. In the year 1997, what is the difference between the Value added (current US$) of Industry and Value added (current US$) of Agriculture?
Offer a terse response. 2.04e+09. In the year 1997, what is the difference between the Value added (current US$) of Manufacturing and Value added (current US$) of Services?
Ensure brevity in your answer.  -1.24e+11. In the year 1997, what is the difference between the Value added (current US$) in Manufacturing and Value added (current US$) in Agriculture?
Offer a very short reply. -3.91e+1. In the year 1997, what is the difference between the Value added (current US$) in Services and Value added (current US$) in Agriculture?
Offer a terse response. 8.50e+1. In the year 1998, what is the difference between the Value added (current US$) of Industry and Value added (current US$) of Manufacturing?
Make the answer very short. 4.26e+1. In the year 1998, what is the difference between the Value added (current US$) in Industry and Value added (current US$) in Services?
Offer a very short reply. -9.02e+1. In the year 1998, what is the difference between the Value added (current US$) of Industry and Value added (current US$) of Agriculture?
Give a very brief answer. -1.98e+08. In the year 1998, what is the difference between the Value added (current US$) of Manufacturing and Value added (current US$) of Services?
Provide a short and direct response. -1.33e+11. In the year 1998, what is the difference between the Value added (current US$) of Manufacturing and Value added (current US$) of Agriculture?
Your answer should be compact. -4.28e+1. In the year 1998, what is the difference between the Value added (current US$) in Services and Value added (current US$) in Agriculture?
Make the answer very short. 9.00e+1. What is the ratio of the Value added (current US$) of Industry in 1991 to that in 1992?
Make the answer very short. 0.93. What is the ratio of the Value added (current US$) in Manufacturing in 1991 to that in 1992?
Provide a succinct answer. 0.93. What is the ratio of the Value added (current US$) of Services in 1991 to that in 1992?
Ensure brevity in your answer.  0.93. What is the ratio of the Value added (current US$) in Agriculture in 1991 to that in 1992?
Your answer should be very brief. 0.96. What is the ratio of the Value added (current US$) in Industry in 1991 to that in 1993?
Your response must be concise. 0.96. What is the ratio of the Value added (current US$) of Manufacturing in 1991 to that in 1993?
Your response must be concise. 0.95. What is the ratio of the Value added (current US$) of Services in 1991 to that in 1993?
Your response must be concise. 0.95. What is the ratio of the Value added (current US$) in Agriculture in 1991 to that in 1993?
Offer a terse response. 0.98. What is the ratio of the Value added (current US$) in Industry in 1991 to that in 1994?
Provide a succinct answer. 0.79. What is the ratio of the Value added (current US$) of Manufacturing in 1991 to that in 1994?
Offer a terse response. 0.77. What is the ratio of the Value added (current US$) in Services in 1991 to that in 1994?
Make the answer very short. 0.82. What is the ratio of the Value added (current US$) in Agriculture in 1991 to that in 1994?
Give a very brief answer. 0.85. What is the ratio of the Value added (current US$) of Industry in 1991 to that in 1995?
Your response must be concise. 0.69. What is the ratio of the Value added (current US$) of Manufacturing in 1991 to that in 1995?
Provide a succinct answer. 0.66. What is the ratio of the Value added (current US$) in Services in 1991 to that in 1995?
Provide a succinct answer. 0.73. What is the ratio of the Value added (current US$) in Agriculture in 1991 to that in 1995?
Make the answer very short. 0.84. What is the ratio of the Value added (current US$) in Industry in 1991 to that in 1996?
Make the answer very short. 0.65. What is the ratio of the Value added (current US$) in Manufacturing in 1991 to that in 1996?
Your answer should be very brief. 0.61. What is the ratio of the Value added (current US$) of Agriculture in 1991 to that in 1996?
Provide a succinct answer. 0.74. What is the ratio of the Value added (current US$) in Industry in 1991 to that in 1997?
Offer a very short reply. 0.62. What is the ratio of the Value added (current US$) of Manufacturing in 1991 to that in 1997?
Offer a very short reply. 0.62. What is the ratio of the Value added (current US$) of Services in 1991 to that in 1997?
Give a very brief answer. 0.61. What is the ratio of the Value added (current US$) in Agriculture in 1991 to that in 1997?
Ensure brevity in your answer.  0.73. What is the ratio of the Value added (current US$) in Industry in 1991 to that in 1998?
Your answer should be compact. 0.62. What is the ratio of the Value added (current US$) in Manufacturing in 1991 to that in 1998?
Make the answer very short. 0.64. What is the ratio of the Value added (current US$) of Services in 1991 to that in 1998?
Your answer should be compact. 0.59. What is the ratio of the Value added (current US$) of Agriculture in 1991 to that in 1998?
Provide a short and direct response. 0.72. What is the ratio of the Value added (current US$) of Industry in 1992 to that in 1993?
Ensure brevity in your answer.  1.03. What is the ratio of the Value added (current US$) in Manufacturing in 1992 to that in 1993?
Offer a very short reply. 1.02. What is the ratio of the Value added (current US$) in Services in 1992 to that in 1993?
Keep it short and to the point. 1.01. What is the ratio of the Value added (current US$) of Agriculture in 1992 to that in 1993?
Your answer should be very brief. 1.02. What is the ratio of the Value added (current US$) in Industry in 1992 to that in 1994?
Offer a very short reply. 0.85. What is the ratio of the Value added (current US$) in Manufacturing in 1992 to that in 1994?
Give a very brief answer. 0.83. What is the ratio of the Value added (current US$) in Services in 1992 to that in 1994?
Offer a terse response. 0.88. What is the ratio of the Value added (current US$) in Agriculture in 1992 to that in 1994?
Give a very brief answer. 0.89. What is the ratio of the Value added (current US$) of Industry in 1992 to that in 1995?
Provide a succinct answer. 0.75. What is the ratio of the Value added (current US$) in Manufacturing in 1992 to that in 1995?
Make the answer very short. 0.71. What is the ratio of the Value added (current US$) in Services in 1992 to that in 1995?
Your response must be concise. 0.78. What is the ratio of the Value added (current US$) in Agriculture in 1992 to that in 1995?
Ensure brevity in your answer.  0.87. What is the ratio of the Value added (current US$) of Industry in 1992 to that in 1996?
Provide a short and direct response. 0.7. What is the ratio of the Value added (current US$) of Manufacturing in 1992 to that in 1996?
Offer a terse response. 0.66. What is the ratio of the Value added (current US$) in Services in 1992 to that in 1996?
Your response must be concise. 0.71. What is the ratio of the Value added (current US$) in Agriculture in 1992 to that in 1996?
Offer a very short reply. 0.77. What is the ratio of the Value added (current US$) of Industry in 1992 to that in 1997?
Offer a terse response. 0.67. What is the ratio of the Value added (current US$) in Manufacturing in 1992 to that in 1997?
Offer a very short reply. 0.66. What is the ratio of the Value added (current US$) of Services in 1992 to that in 1997?
Provide a short and direct response. 0.65. What is the ratio of the Value added (current US$) in Agriculture in 1992 to that in 1997?
Your answer should be compact. 0.76. What is the ratio of the Value added (current US$) in Industry in 1992 to that in 1998?
Your answer should be very brief. 0.67. What is the ratio of the Value added (current US$) in Manufacturing in 1992 to that in 1998?
Offer a terse response. 0.69. What is the ratio of the Value added (current US$) of Services in 1992 to that in 1998?
Your answer should be compact. 0.63. What is the ratio of the Value added (current US$) of Agriculture in 1992 to that in 1998?
Keep it short and to the point. 0.75. What is the ratio of the Value added (current US$) of Industry in 1993 to that in 1994?
Your answer should be very brief. 0.83. What is the ratio of the Value added (current US$) of Manufacturing in 1993 to that in 1994?
Your response must be concise. 0.81. What is the ratio of the Value added (current US$) of Services in 1993 to that in 1994?
Ensure brevity in your answer.  0.87. What is the ratio of the Value added (current US$) in Agriculture in 1993 to that in 1994?
Offer a terse response. 0.87. What is the ratio of the Value added (current US$) in Industry in 1993 to that in 1995?
Offer a terse response. 0.73. What is the ratio of the Value added (current US$) in Manufacturing in 1993 to that in 1995?
Provide a short and direct response. 0.69. What is the ratio of the Value added (current US$) in Services in 1993 to that in 1995?
Give a very brief answer. 0.77. What is the ratio of the Value added (current US$) of Agriculture in 1993 to that in 1995?
Provide a short and direct response. 0.85. What is the ratio of the Value added (current US$) of Industry in 1993 to that in 1996?
Offer a very short reply. 0.68. What is the ratio of the Value added (current US$) of Manufacturing in 1993 to that in 1996?
Make the answer very short. 0.64. What is the ratio of the Value added (current US$) of Services in 1993 to that in 1996?
Offer a terse response. 0.7. What is the ratio of the Value added (current US$) in Agriculture in 1993 to that in 1996?
Give a very brief answer. 0.75. What is the ratio of the Value added (current US$) in Industry in 1993 to that in 1997?
Give a very brief answer. 0.65. What is the ratio of the Value added (current US$) of Manufacturing in 1993 to that in 1997?
Offer a very short reply. 0.65. What is the ratio of the Value added (current US$) in Services in 1993 to that in 1997?
Offer a terse response. 0.64. What is the ratio of the Value added (current US$) of Agriculture in 1993 to that in 1997?
Provide a succinct answer. 0.74. What is the ratio of the Value added (current US$) in Industry in 1993 to that in 1998?
Your answer should be very brief. 0.65. What is the ratio of the Value added (current US$) in Manufacturing in 1993 to that in 1998?
Provide a short and direct response. 0.67. What is the ratio of the Value added (current US$) of Services in 1993 to that in 1998?
Offer a terse response. 0.62. What is the ratio of the Value added (current US$) of Agriculture in 1993 to that in 1998?
Give a very brief answer. 0.73. What is the ratio of the Value added (current US$) in Industry in 1994 to that in 1995?
Offer a terse response. 0.88. What is the ratio of the Value added (current US$) in Manufacturing in 1994 to that in 1995?
Provide a succinct answer. 0.85. What is the ratio of the Value added (current US$) in Services in 1994 to that in 1995?
Your response must be concise. 0.89. What is the ratio of the Value added (current US$) in Agriculture in 1994 to that in 1995?
Make the answer very short. 0.98. What is the ratio of the Value added (current US$) in Industry in 1994 to that in 1996?
Keep it short and to the point. 0.82. What is the ratio of the Value added (current US$) of Manufacturing in 1994 to that in 1996?
Offer a very short reply. 0.79. What is the ratio of the Value added (current US$) of Services in 1994 to that in 1996?
Provide a short and direct response. 0.81. What is the ratio of the Value added (current US$) of Agriculture in 1994 to that in 1996?
Offer a very short reply. 0.86. What is the ratio of the Value added (current US$) of Industry in 1994 to that in 1997?
Offer a very short reply. 0.78. What is the ratio of the Value added (current US$) of Manufacturing in 1994 to that in 1997?
Provide a succinct answer. 0.8. What is the ratio of the Value added (current US$) of Services in 1994 to that in 1997?
Make the answer very short. 0.74. What is the ratio of the Value added (current US$) in Agriculture in 1994 to that in 1997?
Your answer should be very brief. 0.85. What is the ratio of the Value added (current US$) in Industry in 1994 to that in 1998?
Offer a very short reply. 0.79. What is the ratio of the Value added (current US$) of Manufacturing in 1994 to that in 1998?
Make the answer very short. 0.83. What is the ratio of the Value added (current US$) of Services in 1994 to that in 1998?
Offer a very short reply. 0.72. What is the ratio of the Value added (current US$) of Agriculture in 1994 to that in 1998?
Offer a terse response. 0.84. What is the ratio of the Value added (current US$) of Industry in 1995 to that in 1996?
Provide a short and direct response. 0.94. What is the ratio of the Value added (current US$) of Services in 1995 to that in 1996?
Offer a terse response. 0.91. What is the ratio of the Value added (current US$) in Agriculture in 1995 to that in 1996?
Ensure brevity in your answer.  0.88. What is the ratio of the Value added (current US$) of Industry in 1995 to that in 1997?
Offer a very short reply. 0.89. What is the ratio of the Value added (current US$) of Manufacturing in 1995 to that in 1997?
Provide a short and direct response. 0.94. What is the ratio of the Value added (current US$) in Services in 1995 to that in 1997?
Provide a succinct answer. 0.83. What is the ratio of the Value added (current US$) of Agriculture in 1995 to that in 1997?
Give a very brief answer. 0.87. What is the ratio of the Value added (current US$) in Industry in 1995 to that in 1998?
Give a very brief answer. 0.9. What is the ratio of the Value added (current US$) of Manufacturing in 1995 to that in 1998?
Your answer should be compact. 0.97. What is the ratio of the Value added (current US$) of Services in 1995 to that in 1998?
Provide a succinct answer. 0.81. What is the ratio of the Value added (current US$) in Agriculture in 1995 to that in 1998?
Your response must be concise. 0.86. What is the ratio of the Value added (current US$) of Industry in 1996 to that in 1997?
Give a very brief answer. 0.95. What is the ratio of the Value added (current US$) of Manufacturing in 1996 to that in 1997?
Offer a terse response. 1.01. What is the ratio of the Value added (current US$) in Services in 1996 to that in 1997?
Your answer should be compact. 0.91. What is the ratio of the Value added (current US$) of Agriculture in 1996 to that in 1997?
Give a very brief answer. 0.99. What is the ratio of the Value added (current US$) in Industry in 1996 to that in 1998?
Offer a very short reply. 0.96. What is the ratio of the Value added (current US$) in Manufacturing in 1996 to that in 1998?
Offer a terse response. 1.04. What is the ratio of the Value added (current US$) in Services in 1996 to that in 1998?
Ensure brevity in your answer.  0.88. What is the ratio of the Value added (current US$) of Agriculture in 1996 to that in 1998?
Keep it short and to the point. 0.97. What is the ratio of the Value added (current US$) in Industry in 1997 to that in 1998?
Your response must be concise. 1.01. What is the ratio of the Value added (current US$) in Manufacturing in 1997 to that in 1998?
Keep it short and to the point. 1.04. What is the ratio of the Value added (current US$) of Services in 1997 to that in 1998?
Offer a very short reply. 0.97. What is the ratio of the Value added (current US$) in Agriculture in 1997 to that in 1998?
Keep it short and to the point. 0.99. What is the difference between the highest and the second highest Value added (current US$) in Industry?
Give a very brief answer. 7.66e+08. What is the difference between the highest and the second highest Value added (current US$) of Manufacturing?
Your answer should be compact. 3.95e+08. What is the difference between the highest and the second highest Value added (current US$) of Services?
Your answer should be very brief. 6.45e+09. What is the difference between the highest and the second highest Value added (current US$) in Agriculture?
Provide a succinct answer. 1.47e+09. What is the difference between the highest and the lowest Value added (current US$) in Industry?
Your answer should be compact. 3.93e+1. What is the difference between the highest and the lowest Value added (current US$) in Manufacturing?
Provide a short and direct response. 2.41e+1. What is the difference between the highest and the lowest Value added (current US$) in Services?
Your response must be concise. 7.92e+1. What is the difference between the highest and the lowest Value added (current US$) in Agriculture?
Ensure brevity in your answer.  2.88e+1. 